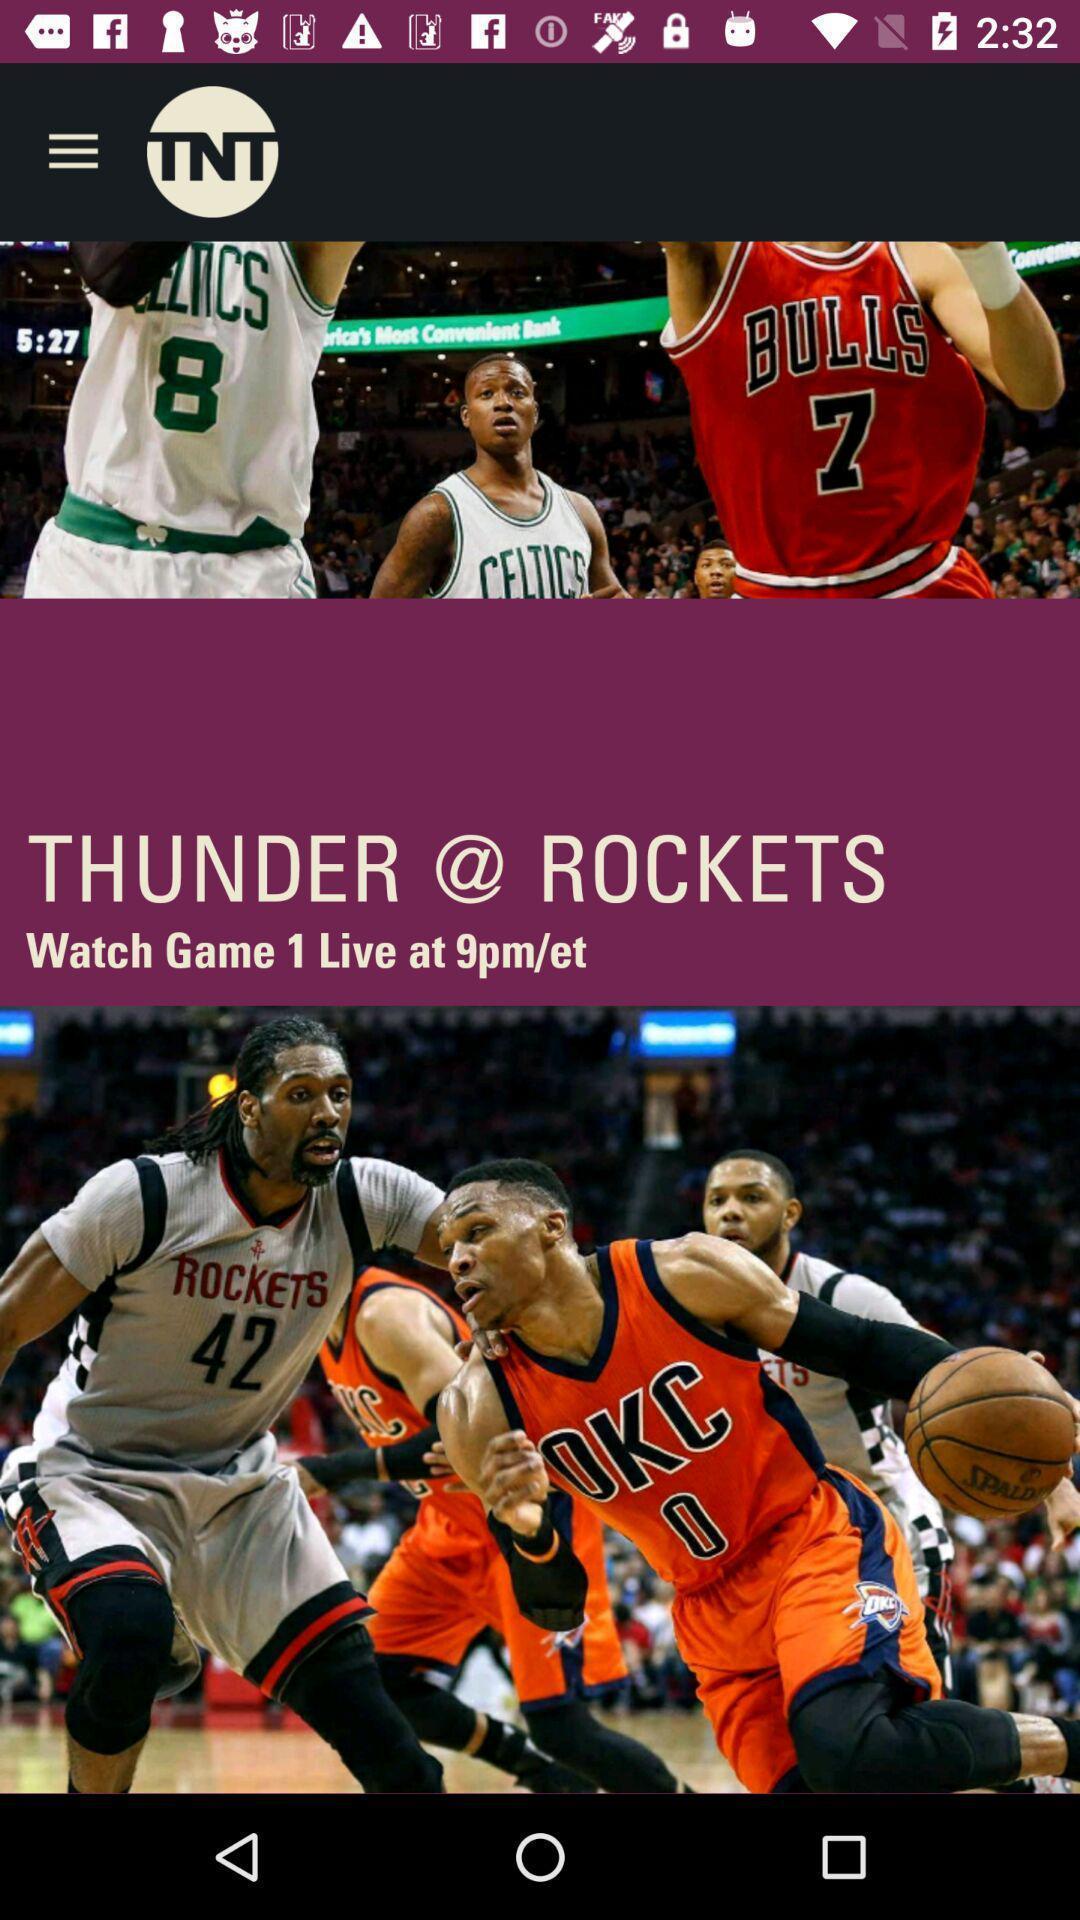Tell me what you see in this picture. Screen displaying page of an sports application. 